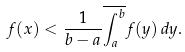Convert formula to latex. <formula><loc_0><loc_0><loc_500><loc_500>f ( x ) < \frac { 1 } { b - a } \overline { \int _ { a } ^ { b } } { f ( y ) \, d y } .</formula> 